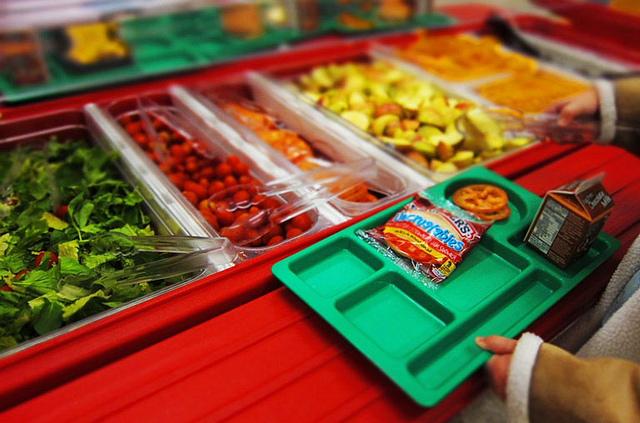Is the person eating a healthy lunch?
Concise answer only. Yes. What is the person drinking?
Short answer required. Chocolate milk. What are the tongs used for?
Give a very brief answer. Picking up food. 